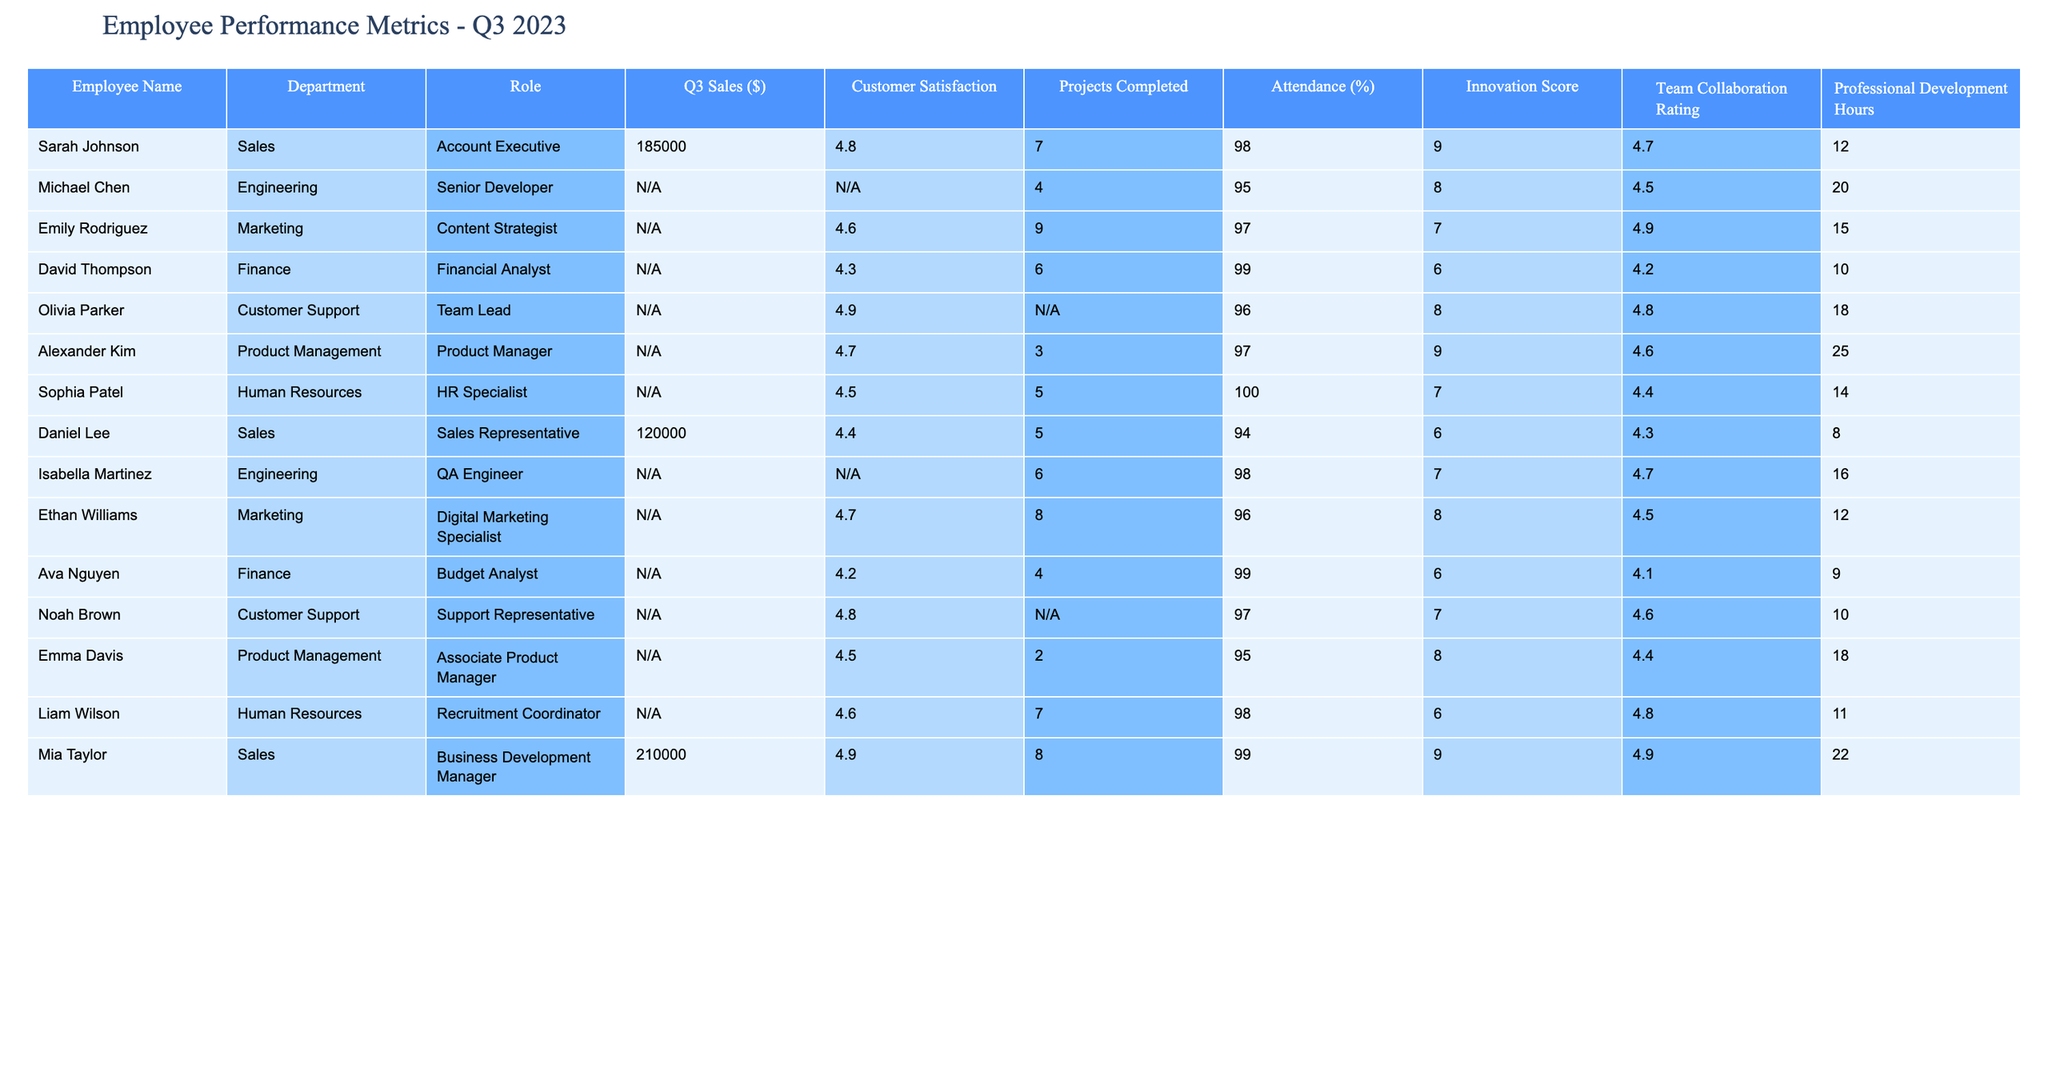What's the highest sales figure recorded in Q3 2023? The table shows that Mia Taylor, with a role as a Business Development Manager, has the highest sales figure at $210,000.
Answer: $210,000 Which department has the highest average customer satisfaction score? By examining the customer satisfaction scores in each department, we can calculate the average: Sales has an average of 4.7, Engineering has 4.6, Marketing has 4.7, Finance has 4.3, Customer Support has 4.8, Product Management has 4.6, and Human Resources has 4.6. The highest average is from Customer Support with 4.8.
Answer: Customer Support How many projects were completed by all employees in Q3 2023? The total number of projects completed is derived by summing the completed projects across employees who reported a value: 7 (Sarah) + 4 (Michael) + 9 (Emily) + 6 (David) + 3 (Alexander) + 5 (Sophia) + 5 (Daniel) + 6 (Isabella) + 8 (Ethan) + 4 (Ava) + 2 (Emma) + 7 (Liam) + 8 (Mia) = 66.
Answer: 66 Did any employee achieve a perfect attendance rate? The table indicates that Sophia Patel is the only employee with a perfect attendance rate of 100%.
Answer: Yes What is the average innovation score for employees in the Sales department? The innovation scores for Sales department employees are 9 (Sarah) and 6 (Daniel) and 9 (Mia). Summing these gives 24, and dividing by 3 (the number of Sales employees) yields an average innovation score of 8.
Answer: 8 Which employee completed the most projects? Sarah Johnson completed the most projects at 7, more than any other employee.
Answer: Sarah Johnson Is there any department where all employees have over 95% attendance? By looking at attendance rates, we see that only the Human Resources department has one person, Liam Wilson, reporting 98%, though there are others with lower attendance scores.
Answer: No What is the attendance rate for the employee with the highest innovation score? Mia Taylor has the highest innovation score of 9, with an attendance rate of 99%.
Answer: 99% How does the customer satisfaction score of the Customer Support department compare to that of Engineering? The Customer Support department has a score of 4.8, while the Engineering department has a score of 4.6. This shows that Customer Support has a higher satisfaction score by 0.2.
Answer: 0.2 higher Which role in Engineering had the highest customer satisfaction? Based on the table, Isabella Martinez, the QA Engineer, does not provide a customer satisfaction score, and Michael Chen, the Senior Developer, has a score of N/A. Thus, we can conclude there is insufficient data to determine the satisfaction of the roles in Engineering.
Answer: N/A 